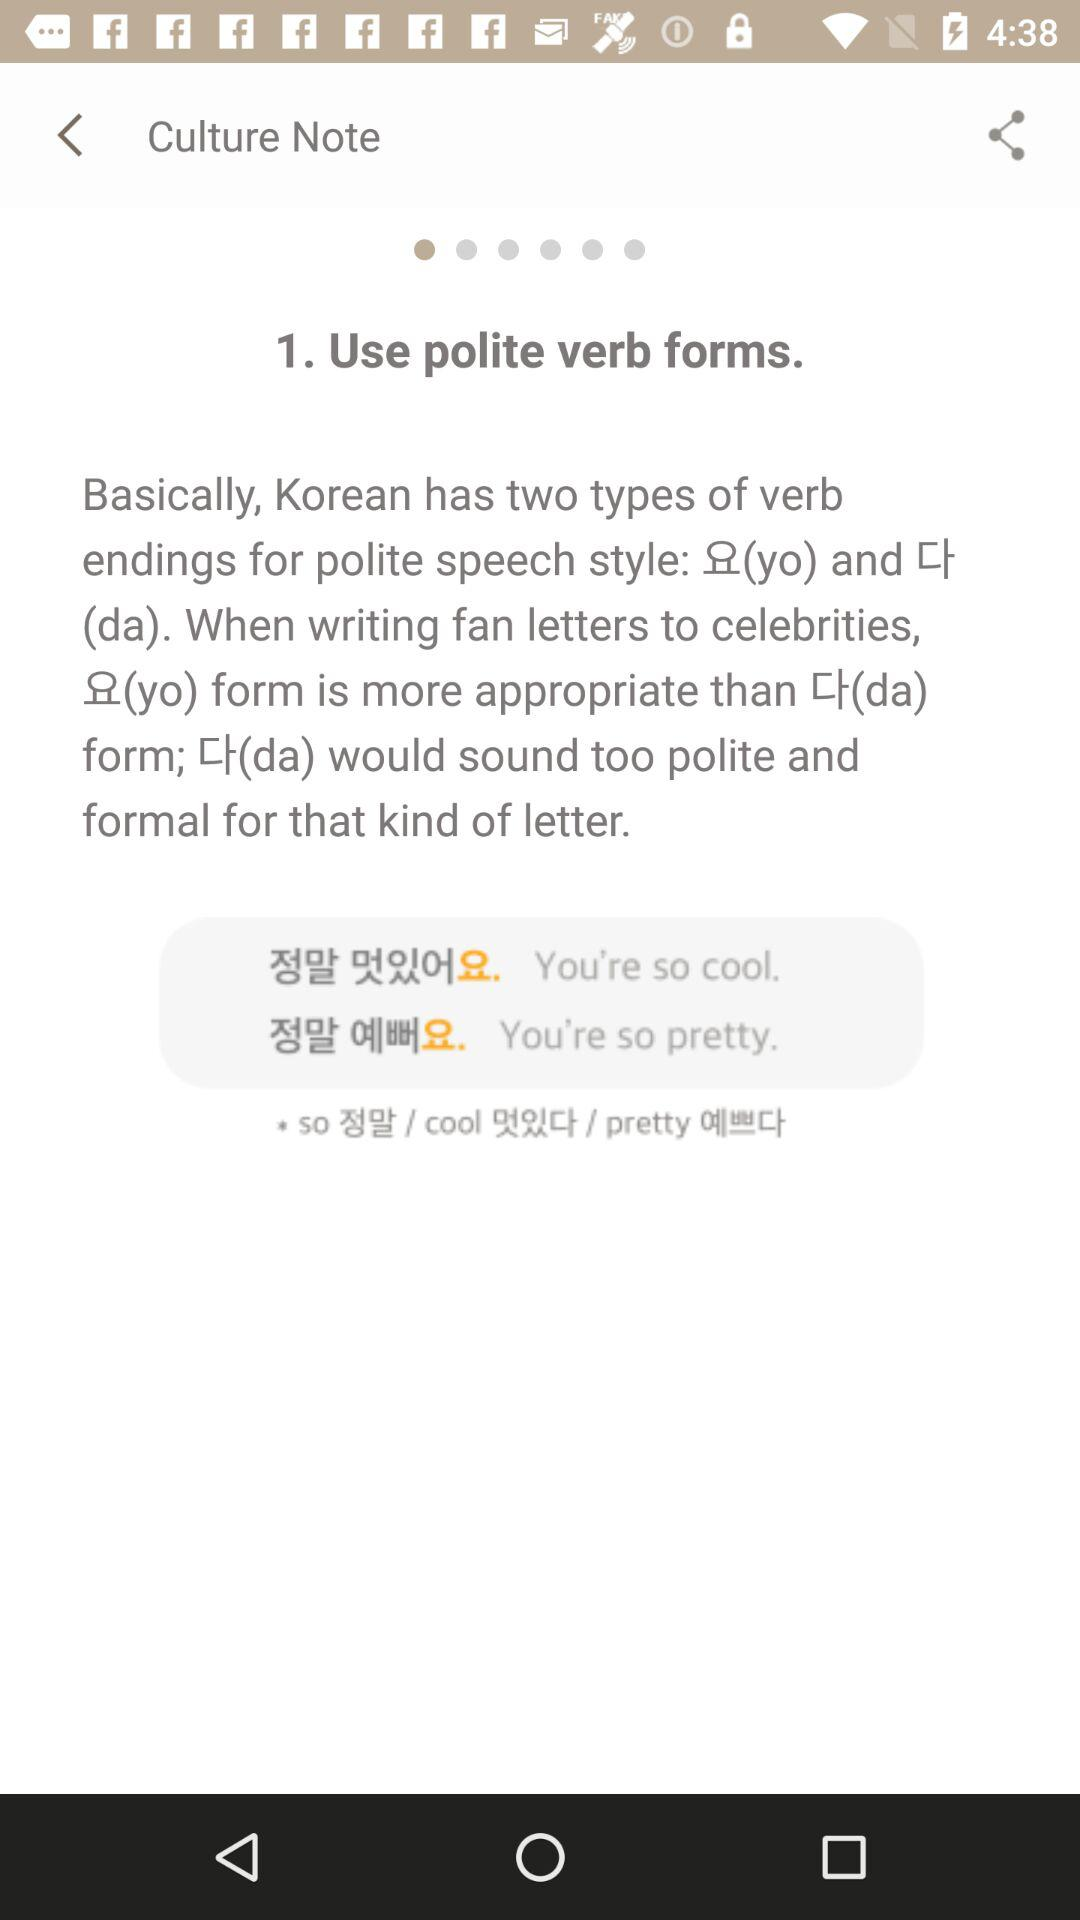How many more examples of polite verb forms are there than examples of rude verb forms?
Answer the question using a single word or phrase. 2 